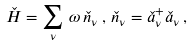<formula> <loc_0><loc_0><loc_500><loc_500>\check { H } = \sum _ { \nu } \, \omega \, \check { n } _ { \nu } \, , \, \check { n } _ { \nu } = \check { a } ^ { + } _ { \nu } \check { a } _ { \nu } \, ,</formula> 